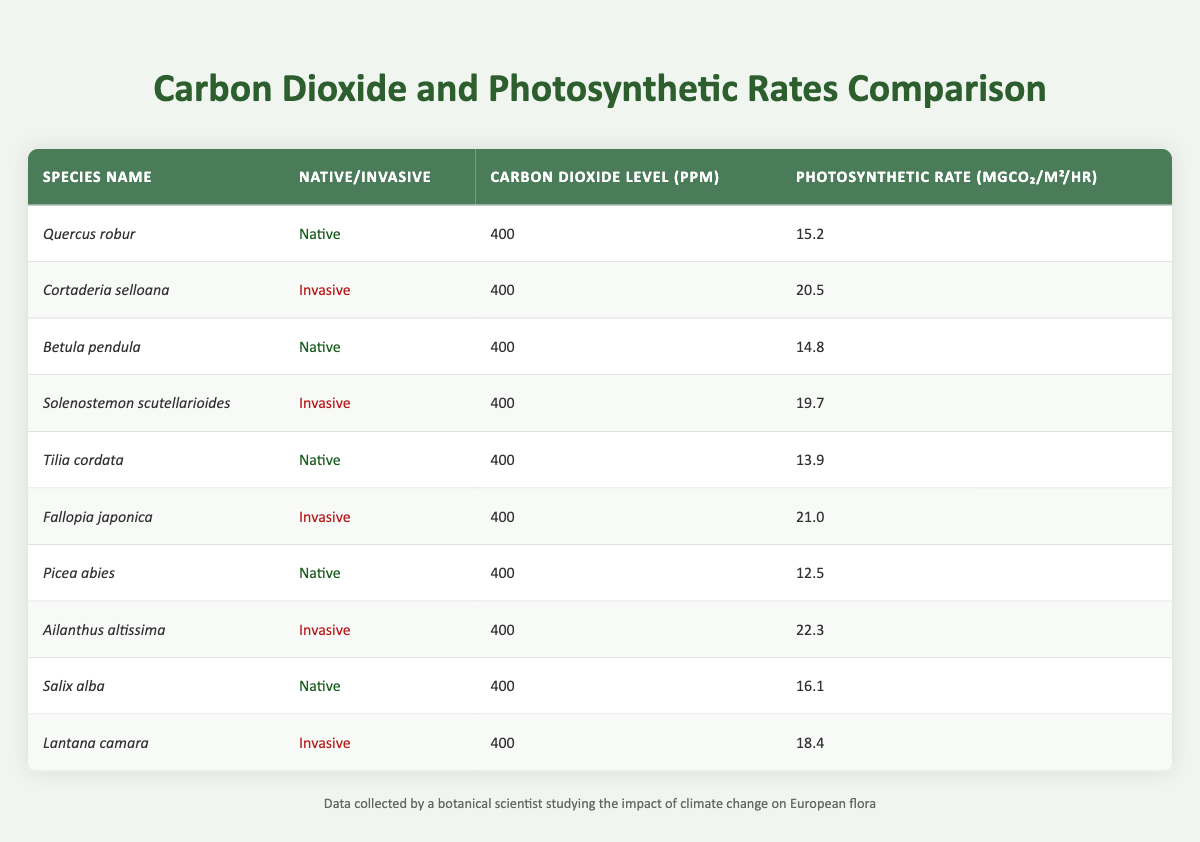What is the photosynthetic rate of Quercus robur? The table provides Quercus robur's photosynthetic rate in the fourth column, which states it is 15.2 mgCO₂/m²/hr.
Answer: 15.2 Which invasive species has the highest photosynthetic rate? By comparing the photosynthetic rates of all invasive species listed, Ailanthus altissima has the highest rate of 22.3 mgCO₂/m²/hr.
Answer: Ailanthus altissima What is the difference in photosynthetic rates between the native and invasive species listed? To find the difference, we calculate the average photosynthetic rate of both groups: the native average is (15.2 + 14.8 + 13.9 + 12.5 + 16.1) / 5 = 14.5 mgCO₂/m²/hr, and the invasive average is (20.5 + 19.7 + 21.0 + 22.3 + 18.4) / 5 = 20.58 mgCO₂/m²/hr. The difference is 20.58 - 14.5 = 6.08 mgCO₂/m²/hr.
Answer: 6.08 Is the carbon dioxide level the same for all species in the table? Yes, the table shows that the carbon dioxide level is consistently 400 ppm for all species listed, confirming a uniform measurement across the board.
Answer: Yes Which native species has the lowest photosynthetic rate? By examining the photosynthetic rates of the native species, Picea abies is identified as having the lowest rate at 12.5 mgCO₂/m²/hr, compared to the others in the same group.
Answer: Picea abies What is the average photosynthetic rate of invasive species? Summing the photosynthetic rates of the invasive species (20.5 + 19.7 + 21.0 + 22.3 + 18.4) gives 102.9 mgCO₂/m²/hr. Dividing this by the number of invasive species, which is 5, results in an average rate of 20.58 mgCO₂/m²/hr.
Answer: 20.58 Are all native species outperformed by invasive species in terms of photosynthetic rate? To determine this, we compare each native species' rate with that of all invasive species. Quercus robur (15.2), Betula pendula (14.8), Tilia cordata (13.9), Picea abies (12.5), and Salix alba (16.1) are all lower than the lowest invasive species rate of 18.4 (Lantana camara). Thus, yes, they are all outperformed.
Answer: Yes What can be concluded about the impact of carbon dioxide levels on the photosynthetic rates of native vs. invasive species? Since all species are under the same carbon dioxide level of 400 ppm, but invasive species consistently show higher rates compared to natives, this suggests that invasive species may be more adaptable or efficient under these conditions.
Answer: Invasive species are more efficient at 400 ppm 